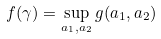Convert formula to latex. <formula><loc_0><loc_0><loc_500><loc_500>f ( \gamma ) = \sup _ { a _ { 1 } , a _ { 2 } } g ( a _ { 1 } , a _ { 2 } )</formula> 